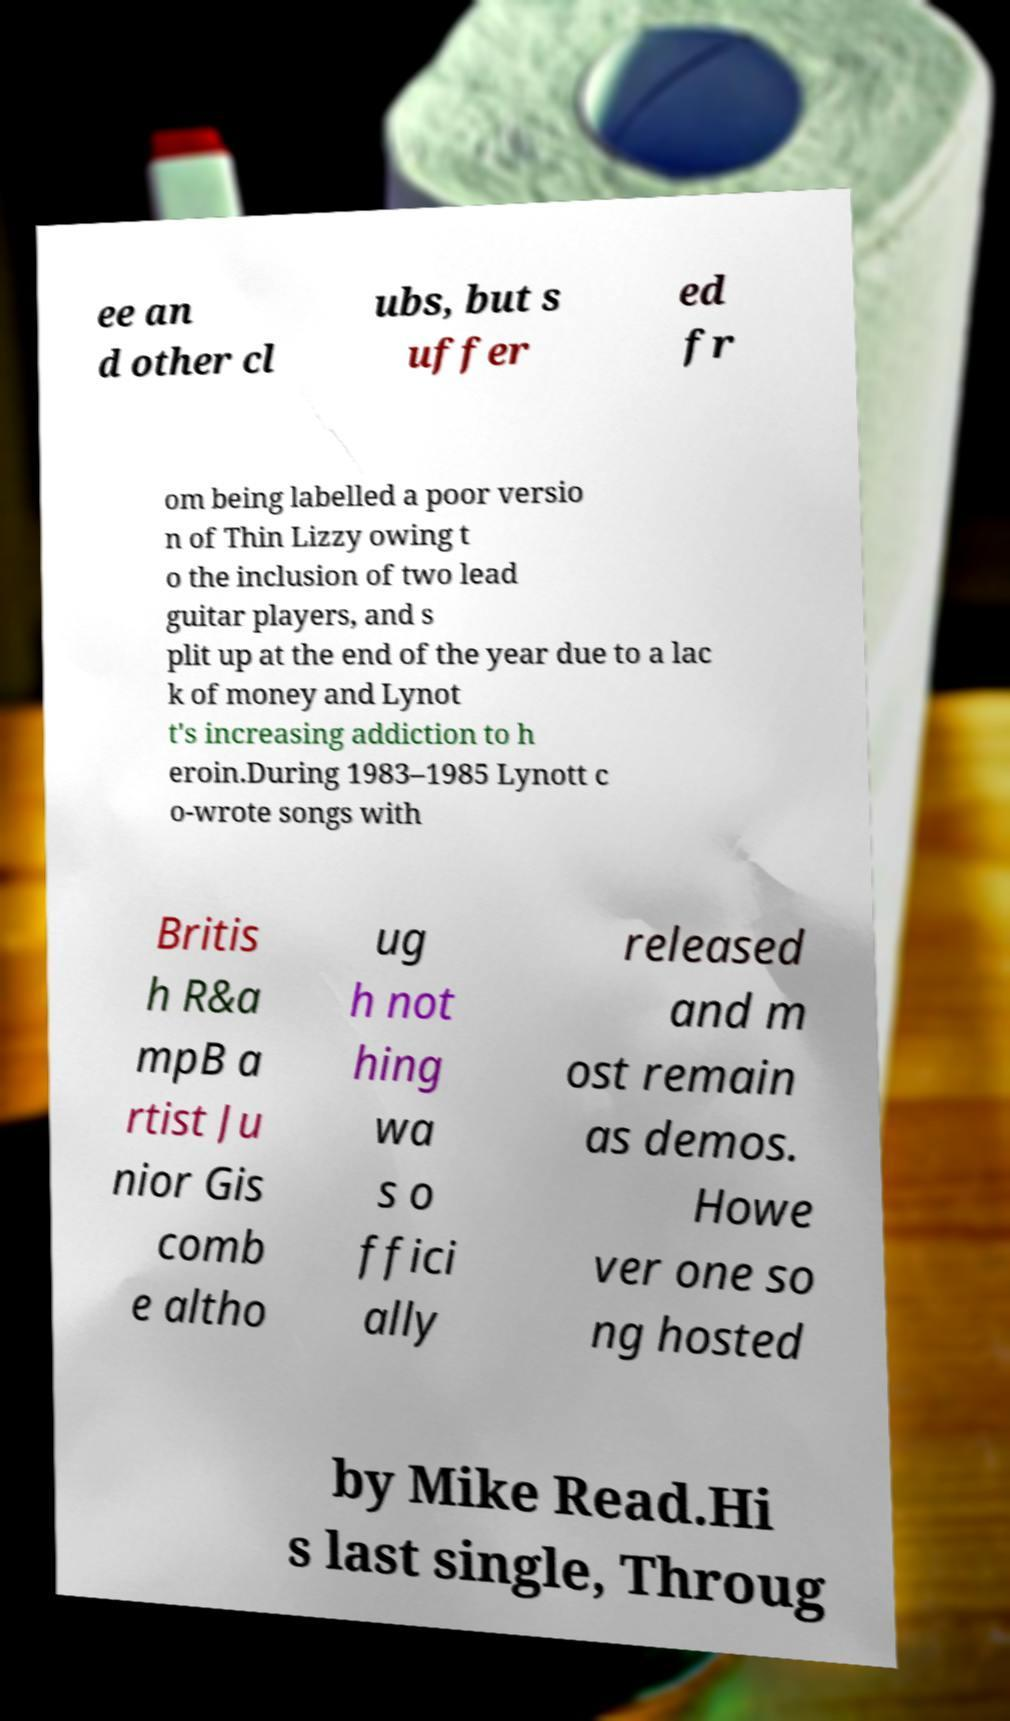I need the written content from this picture converted into text. Can you do that? ee an d other cl ubs, but s uffer ed fr om being labelled a poor versio n of Thin Lizzy owing t o the inclusion of two lead guitar players, and s plit up at the end of the year due to a lac k of money and Lynot t's increasing addiction to h eroin.During 1983–1985 Lynott c o-wrote songs with Britis h R&a mpB a rtist Ju nior Gis comb e altho ug h not hing wa s o ffici ally released and m ost remain as demos. Howe ver one so ng hosted by Mike Read.Hi s last single, Throug 